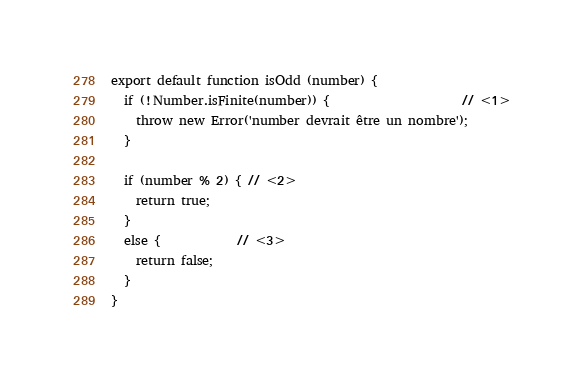<code> <loc_0><loc_0><loc_500><loc_500><_JavaScript_>export default function isOdd (number) {
  if (!Number.isFinite(number)) {                     // <1>
    throw new Error('number devrait être un nombre');
  }

  if (number % 2) { // <2>
    return true;
  }
  else {            // <3>
    return false;
  }
}
</code> 